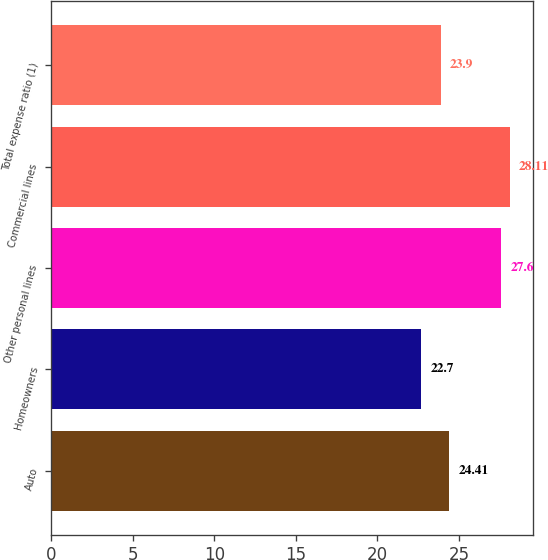<chart> <loc_0><loc_0><loc_500><loc_500><bar_chart><fcel>Auto<fcel>Homeowners<fcel>Other personal lines<fcel>Commercial lines<fcel>Total expense ratio (1)<nl><fcel>24.41<fcel>22.7<fcel>27.6<fcel>28.11<fcel>23.9<nl></chart> 